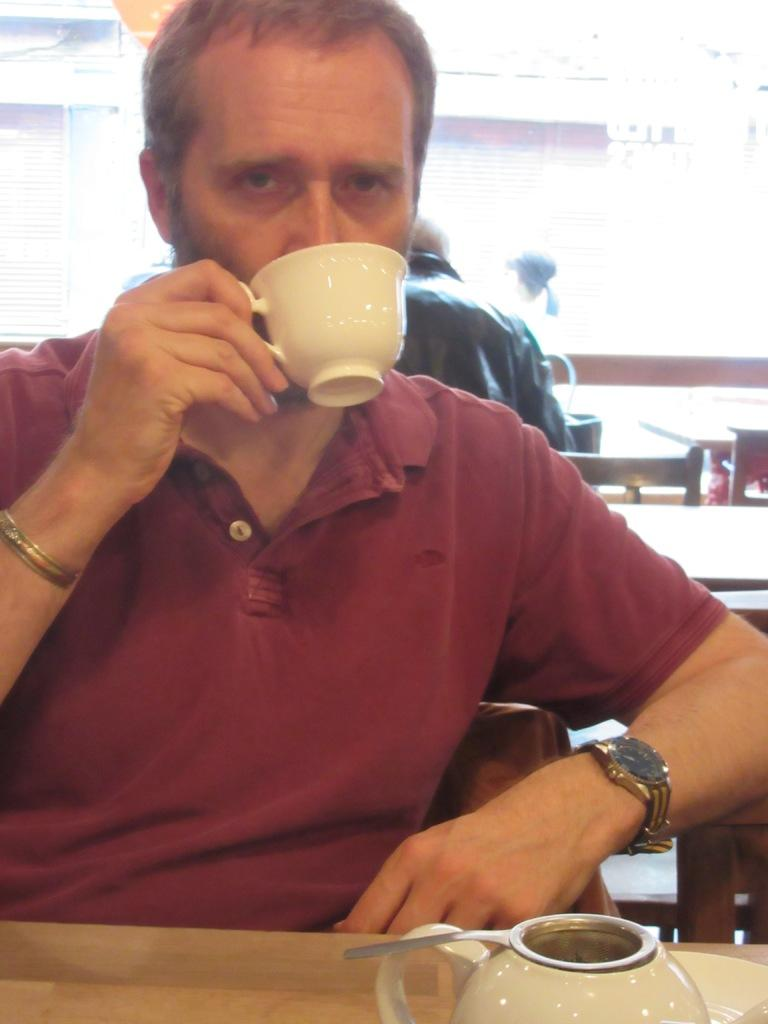What is the main subject of the image? There is a man sitting in the center of the image. What is the man holding in his hand? The man is holding a cup in his hand. What object is present on the table in front of the man? A teapot is placed on the table. What type of disgust can be seen on the man's face in the image? There is no indication of disgust on the man's face in the image. What is the yoke used for in the image? There is no yoke present in the image. 